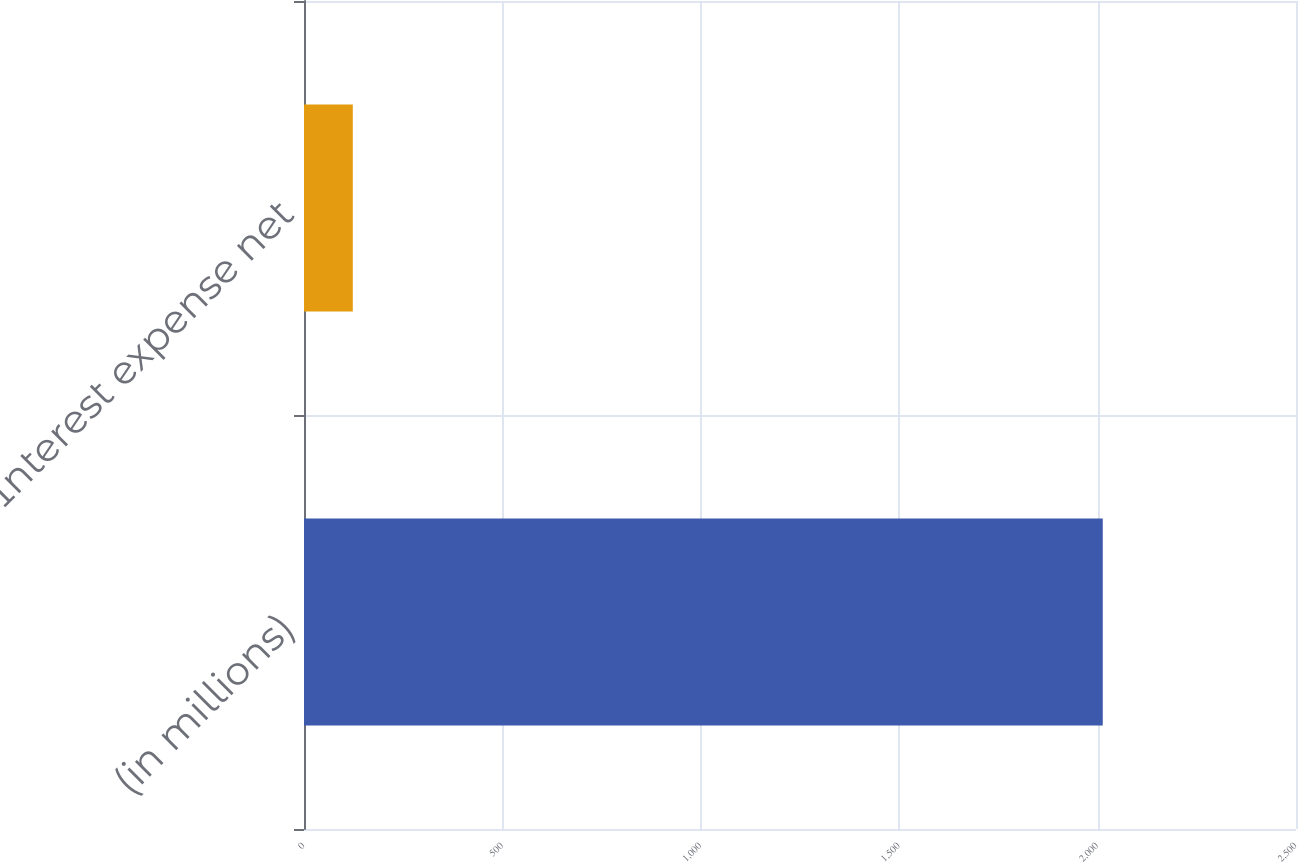Convert chart to OTSL. <chart><loc_0><loc_0><loc_500><loc_500><bar_chart><fcel>(in millions)<fcel>Interest expense net<nl><fcel>2013<fcel>123<nl></chart> 